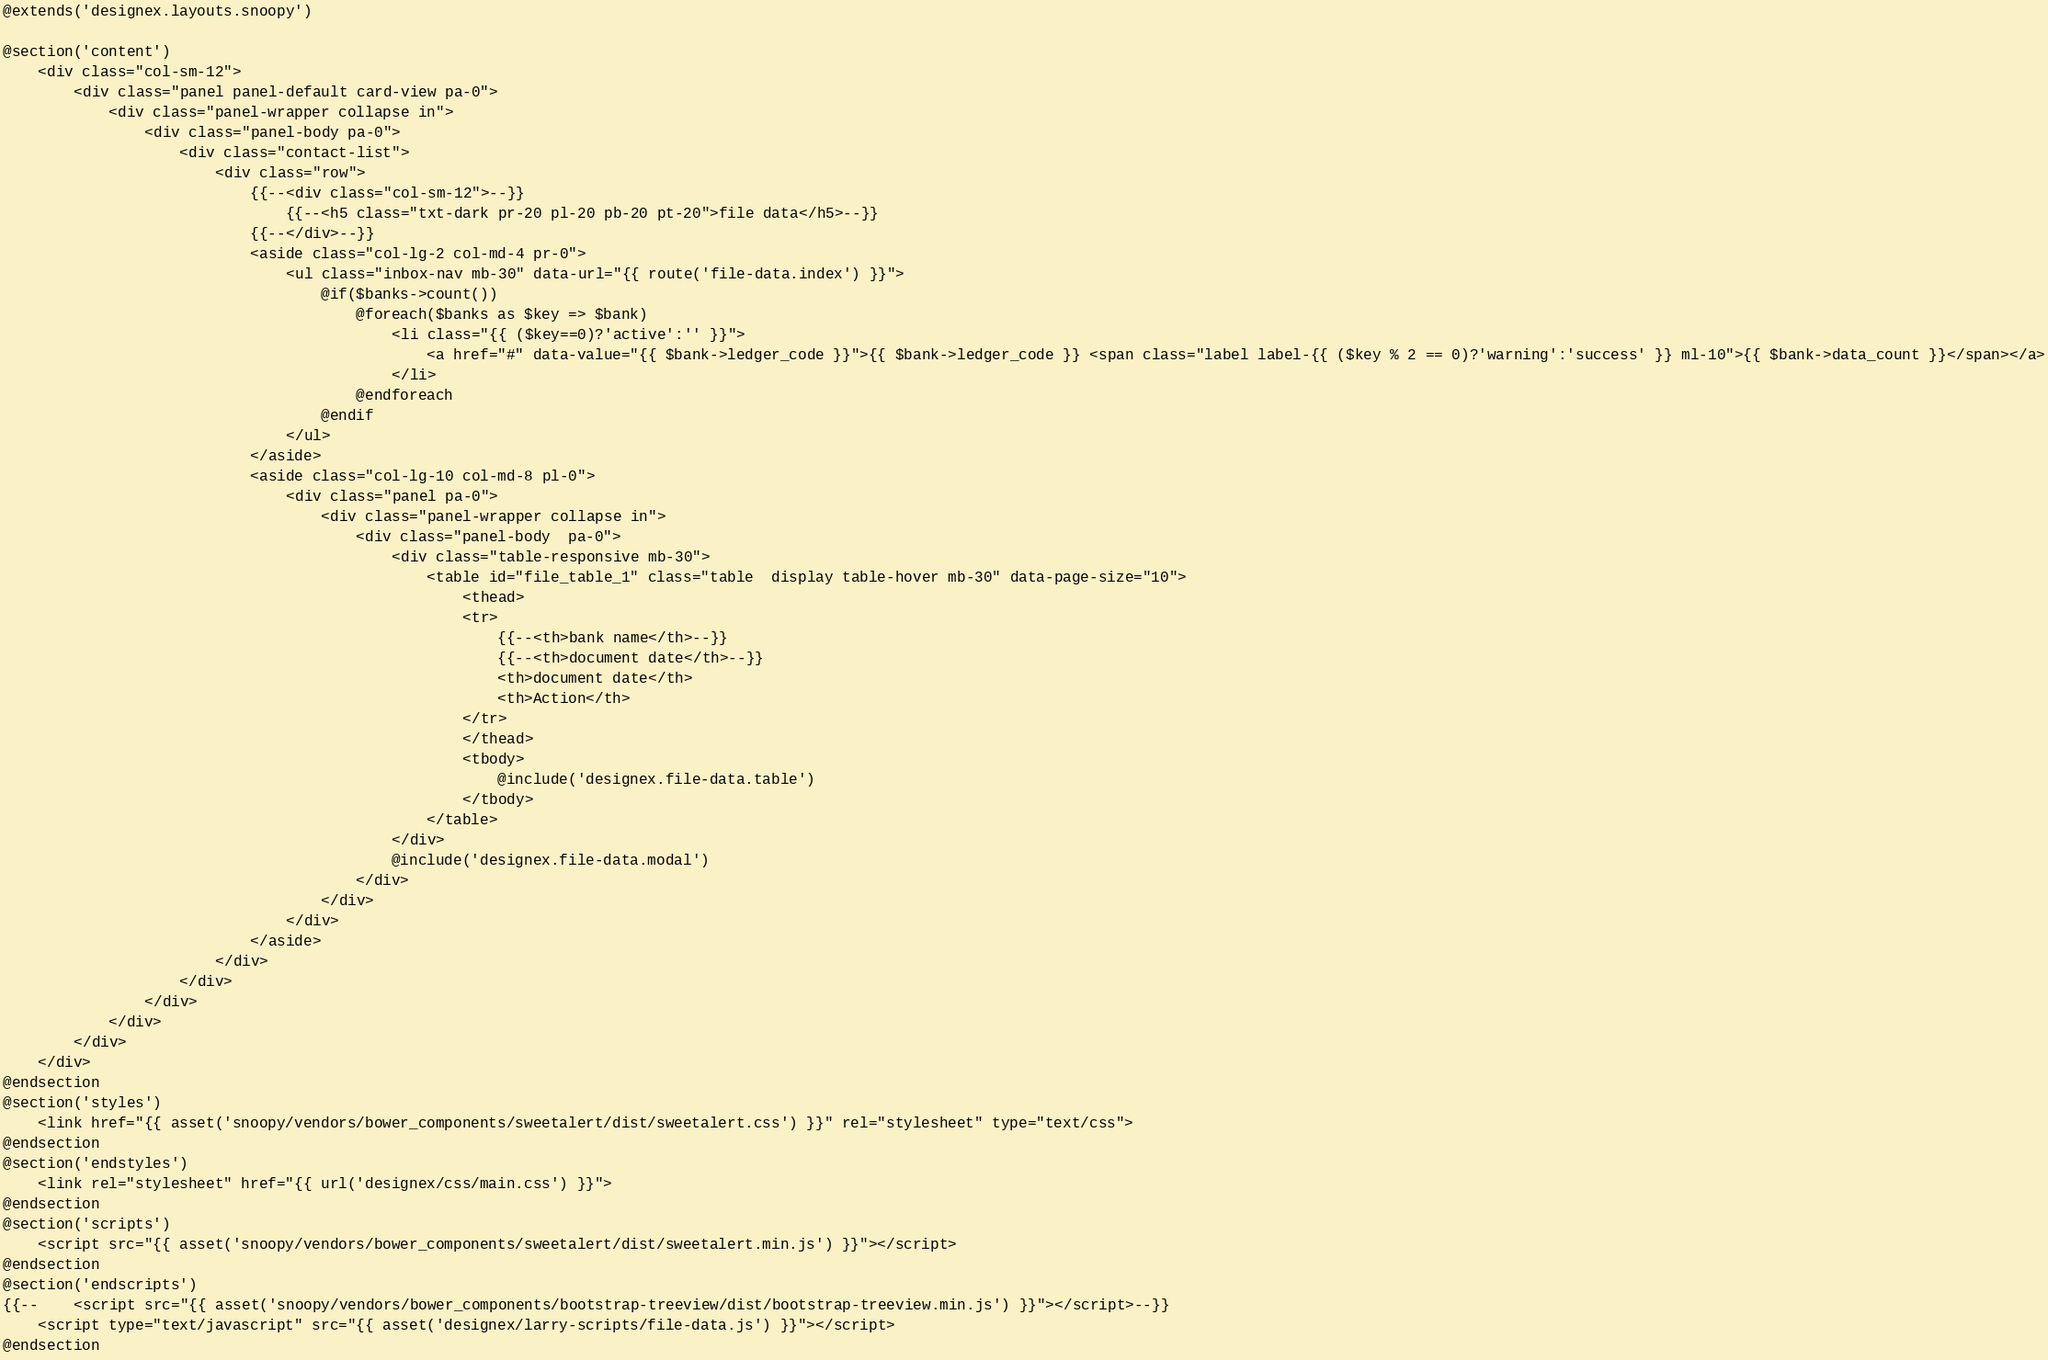<code> <loc_0><loc_0><loc_500><loc_500><_PHP_>@extends('designex.layouts.snoopy')

@section('content')
    <div class="col-sm-12">
        <div class="panel panel-default card-view pa-0">
            <div class="panel-wrapper collapse in">
                <div class="panel-body pa-0">
                    <div class="contact-list">
                        <div class="row">
                            {{--<div class="col-sm-12">--}}
                                {{--<h5 class="txt-dark pr-20 pl-20 pb-20 pt-20">file data</h5>--}}
                            {{--</div>--}}
                            <aside class="col-lg-2 col-md-4 pr-0">
                                <ul class="inbox-nav mb-30" data-url="{{ route('file-data.index') }}">
                                    @if($banks->count())
                                        @foreach($banks as $key => $bank)
                                            <li class="{{ ($key==0)?'active':'' }}">
                                                <a href="#" data-value="{{ $bank->ledger_code }}">{{ $bank->ledger_code }} <span class="label label-{{ ($key % 2 == 0)?'warning':'success' }} ml-10">{{ $bank->data_count }}</span></a>
                                            </li>
                                        @endforeach
                                    @endif
                                </ul>
                            </aside>
                            <aside class="col-lg-10 col-md-8 pl-0">
                                <div class="panel pa-0">
                                    <div class="panel-wrapper collapse in">
                                        <div class="panel-body  pa-0">
                                            <div class="table-responsive mb-30">
                                                <table id="file_table_1" class="table  display table-hover mb-30" data-page-size="10">
                                                    <thead>
                                                    <tr>
                                                        {{--<th>bank name</th>--}}
                                                        {{--<th>document date</th>--}}
                                                        <th>document date</th>
                                                        <th>Action</th>
                                                    </tr>
                                                    </thead>
                                                    <tbody>
                                                        @include('designex.file-data.table')
                                                    </tbody>
                                                </table>
                                            </div>
                                            @include('designex.file-data.modal')
                                        </div>
                                    </div>
                                </div>
                            </aside>
                        </div>
                    </div>
                </div>
            </div>
        </div>
    </div>
@endsection
@section('styles')
    <link href="{{ asset('snoopy/vendors/bower_components/sweetalert/dist/sweetalert.css') }}" rel="stylesheet" type="text/css">
@endsection
@section('endstyles')
    <link rel="stylesheet" href="{{ url('designex/css/main.css') }}">
@endsection
@section('scripts')
    <script src="{{ asset('snoopy/vendors/bower_components/sweetalert/dist/sweetalert.min.js') }}"></script>
@endsection
@section('endscripts')
{{--    <script src="{{ asset('snoopy/vendors/bower_components/bootstrap-treeview/dist/bootstrap-treeview.min.js') }}"></script>--}}
    <script type="text/javascript" src="{{ asset('designex/larry-scripts/file-data.js') }}"></script>
@endsection</code> 